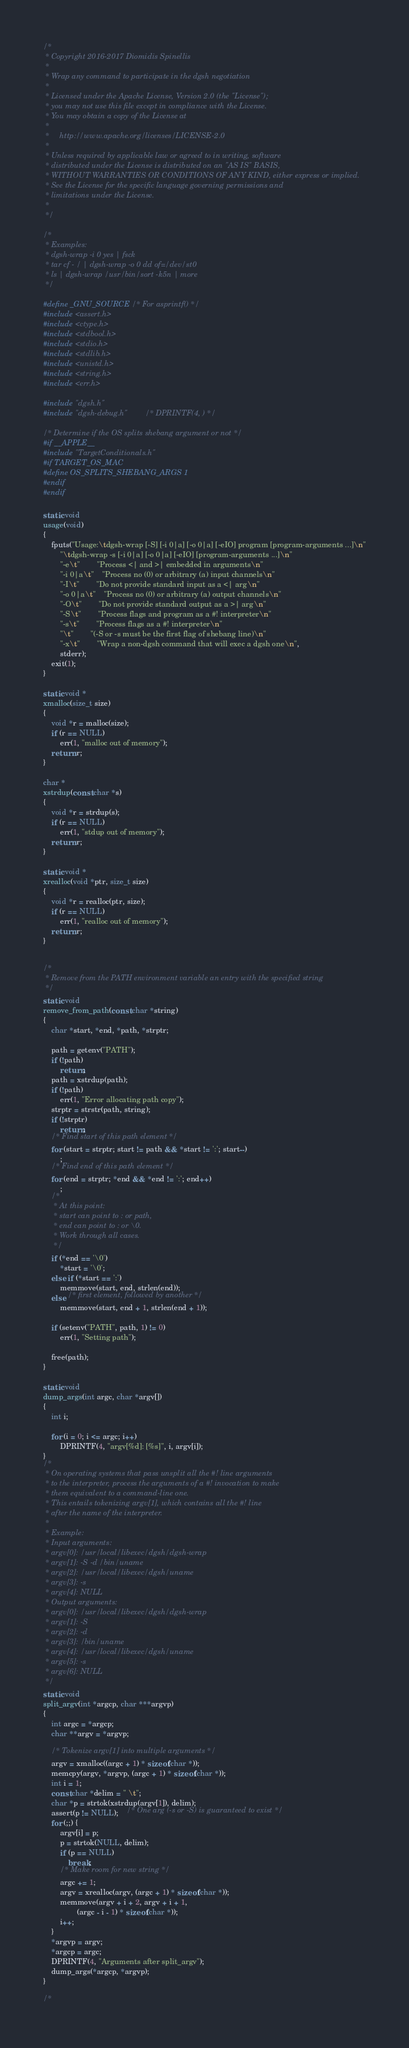<code> <loc_0><loc_0><loc_500><loc_500><_C_>/*
 * Copyright 2016-2017 Diomidis Spinellis
 *
 * Wrap any command to participate in the dgsh negotiation
 *
 * Licensed under the Apache License, Version 2.0 (the "License");
 * you may not use this file except in compliance with the License.
 * You may obtain a copy of the License at
 *
 *     http://www.apache.org/licenses/LICENSE-2.0
 *
 * Unless required by applicable law or agreed to in writing, software
 * distributed under the License is distributed on an "AS IS" BASIS,
 * WITHOUT WARRANTIES OR CONDITIONS OF ANY KIND, either express or implied.
 * See the License for the specific language governing permissions and
 * limitations under the License.
 *
 */

/*
 * Examples:
 * dgsh-wrap -i 0 yes | fsck
 * tar cf - / | dgsh-wrap -o 0 dd of=/dev/st0
 * ls | dgsh-wrap /usr/bin/sort -k5n | more
 */

#define _GNU_SOURCE /* For asprintf() */
#include <assert.h>
#include <ctype.h>
#include <stdbool.h>
#include <stdio.h>
#include <stdlib.h>
#include <unistd.h>
#include <string.h>
#include <err.h>

#include "dgsh.h"
#include "dgsh-debug.h"		/* DPRINTF(4, ) */

/* Determine if the OS splits shebang argument or not */
#if __APPLE__
#include "TargetConditionals.h"
#if TARGET_OS_MAC
#define OS_SPLITS_SHEBANG_ARGS 1
#endif
#endif

static void
usage(void)
{
	fputs("Usage:\tdgsh-wrap [-S] [-i 0|a] [-o 0|a] [-eIO] program [program-arguments ...]\n"
		"\tdgsh-wrap -s [-i 0|a] [-o 0|a] [-eIO] [program-arguments ...]\n"
		"-e\t"		"Process <| and >| embedded in arguments\n"
		"-i 0|a\t"	"Process no (0) or arbitrary (a) input channels\n"
		"-I\t"		"Do not provide standard input as a <| arg\n"
		"-o 0|a\t"	"Process no (0) or arbitrary (a) output channels\n"
		"-O\t"		"Do not provide standard output as a >| arg\n"
		"-S\t"		"Process flags and program as a #! interpreter\n"
		"-s\t"		"Process flags as a #! interpreter\n"
		"\t"		"(-S or -s must be the first flag of shebang line)\n"
		"-x\t"		"Wrap a non-dgsh command that will exec a dgsh one\n",
		stderr);
	exit(1);
}

static void *
xmalloc(size_t size)
{
	void *r = malloc(size);
	if (r == NULL)
		err(1, "malloc out of memory");
	return r;
}

char *
xstrdup(const char *s)
{
	void *r = strdup(s);
	if (r == NULL)
		err(1, "stdup out of memory");
	return r;
}

static void *
xrealloc(void *ptr, size_t size)
{
	void *r = realloc(ptr, size);
	if (r == NULL)
		err(1, "realloc out of memory");
	return r;
}


/*
 * Remove from the PATH environment variable an entry with the specified string
 */
static void
remove_from_path(const char *string)
{
	char *start, *end, *path, *strptr;

	path = getenv("PATH");
	if (!path)
		return;
	path = xstrdup(path);
	if (!path)
		err(1, "Error allocating path copy");
	strptr = strstr(path, string);
	if (!strptr)
		return;
	/* Find start of this path element */
	for (start = strptr; start != path && *start != ':'; start--)
		;
	/* Find end of this path element */
	for (end = strptr; *end && *end != ':'; end++)
		;
	/*
	 * At this point:
	 * start can point to : or path,
	 * end can point to : or \0.
	 * Work through all cases.
	 */
	if (*end == '\0')
		*start = '\0';
	else if (*start == ':')
		memmove(start, end, strlen(end));
	else /* first element, followed by another */
		memmove(start, end + 1, strlen(end + 1));

	if (setenv("PATH", path, 1) != 0)
		err(1, "Setting path");

	free(path);
}

static void
dump_args(int argc, char *argv[])
{
	int i;

	for (i = 0; i <= argc; i++)
		DPRINTF(4, "argv[%d]: [%s]", i, argv[i]);
}
/*
 * On operating systems that pass unsplit all the #! line arguments
 * to the interpreter, process the arguments of a #! invocation to make
 * them equivalent to a command-line one.
 * This entails tokenizing argv[1], which contains all the #! line
 * after the name of the interpreter.
 *
 * Example:
 * Input arguments:
 * argv[0]: /usr/local/libexec/dgsh/dgsh-wrap
 * argv[1]: -S -d /bin/uname
 * argv[2]: /usr/local/libexec/dgsh/uname
 * argv[3]: -s
 * argv[4]: NULL
 * Output arguments:
 * argv[0]: /usr/local/libexec/dgsh/dgsh-wrap
 * argv[1]: -S
 * argv[2]: -d
 * argv[3]: /bin/uname
 * argv[4]: /usr/local/libexec/dgsh/uname
 * argv[5]: -s
 * argv[6]: NULL
 */
static void
split_argv(int *argcp, char ***argvp)
{
	int argc = *argcp;
	char **argv = *argvp;

	/* Tokenize argv[1] into multiple arguments */
	argv = xmalloc((argc + 1) * sizeof(char *));
	memcpy(argv, *argvp, (argc + 1) * sizeof(char *));
	int i = 1;
	const char *delim = " \t";
	char *p = strtok(xstrdup(argv[1]), delim);
	assert(p != NULL);	/* One arg (-s or -S) is guaranteed to exist */
	for (;;) {
		argv[i] = p;
		p = strtok(NULL, delim);
		if (p == NULL)
			break;
		/* Make room for new string */
		argc += 1;
		argv = xrealloc(argv, (argc + 1) * sizeof(char *));
		memmove(argv + i + 2, argv + i + 1,
				(argc - i - 1) * sizeof(char *));
		i++;
	}
	*argvp = argv;
	*argcp = argc;
	DPRINTF(4, "Arguments after split_argv");
	dump_args(*argcp, *argvp);
}

/*</code> 